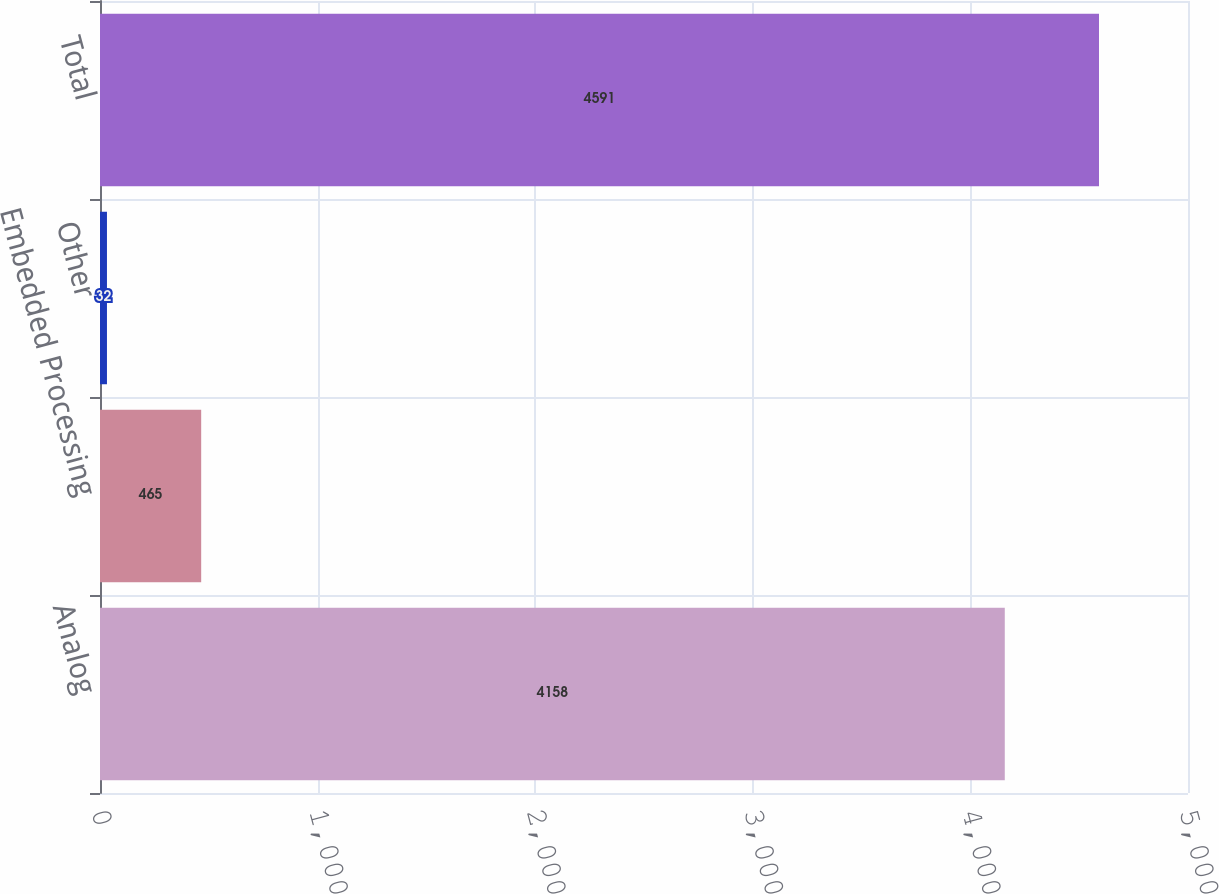<chart> <loc_0><loc_0><loc_500><loc_500><bar_chart><fcel>Analog<fcel>Embedded Processing<fcel>Other<fcel>Total<nl><fcel>4158<fcel>465<fcel>32<fcel>4591<nl></chart> 